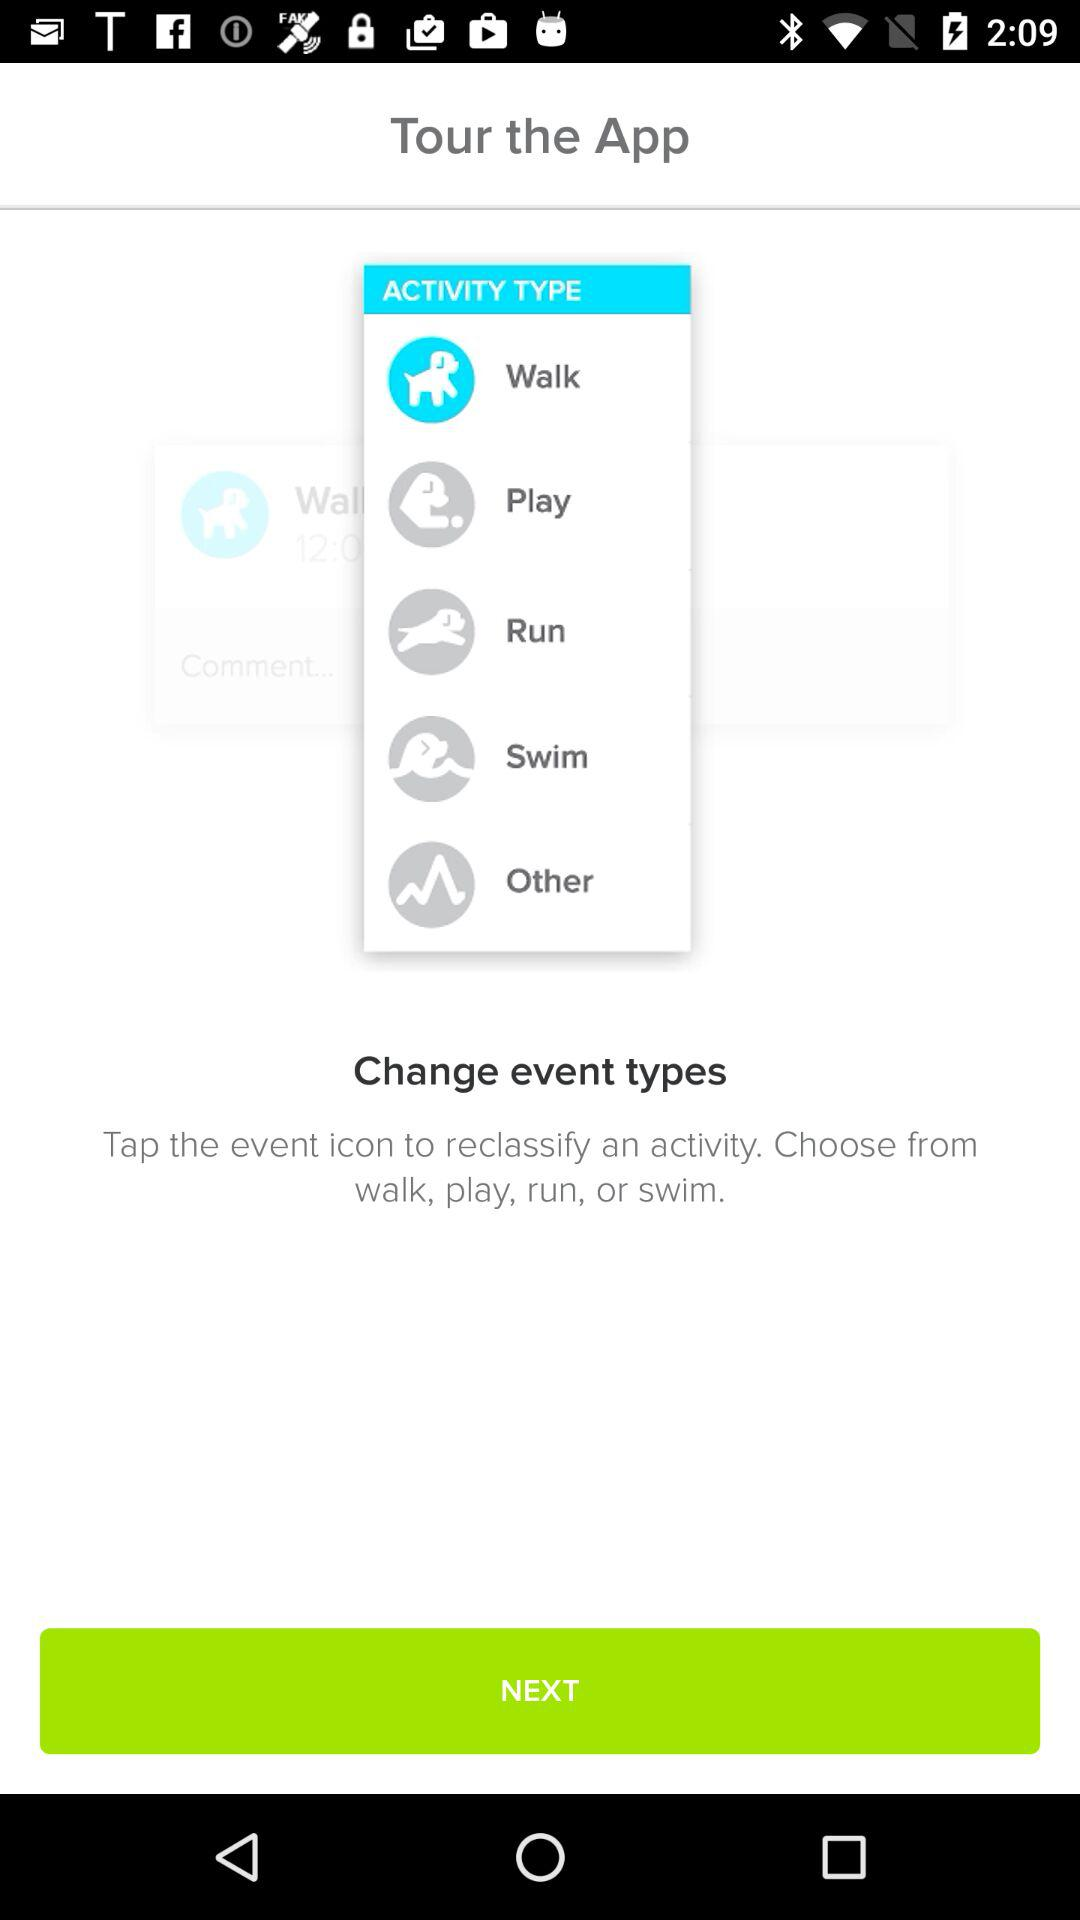What type of activity is selected? The selected type of activity is walk. 